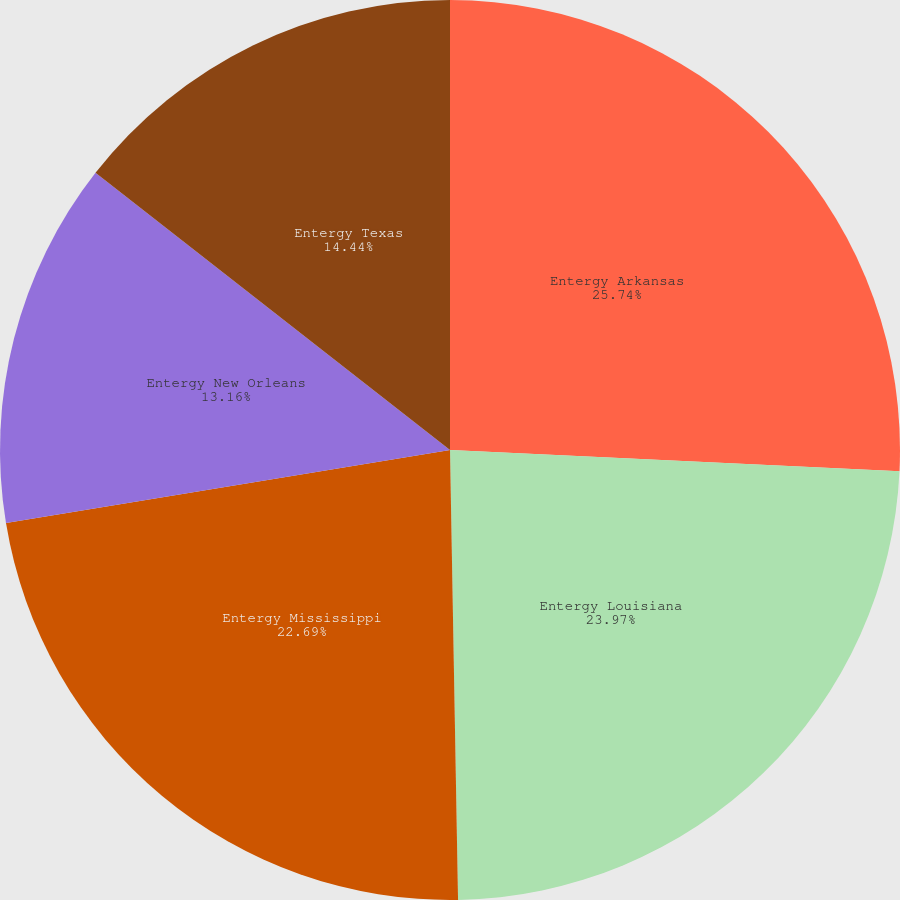<chart> <loc_0><loc_0><loc_500><loc_500><pie_chart><fcel>Entergy Arkansas<fcel>Entergy Louisiana<fcel>Entergy Mississippi<fcel>Entergy New Orleans<fcel>Entergy Texas<nl><fcel>25.75%<fcel>23.97%<fcel>22.69%<fcel>13.16%<fcel>14.44%<nl></chart> 